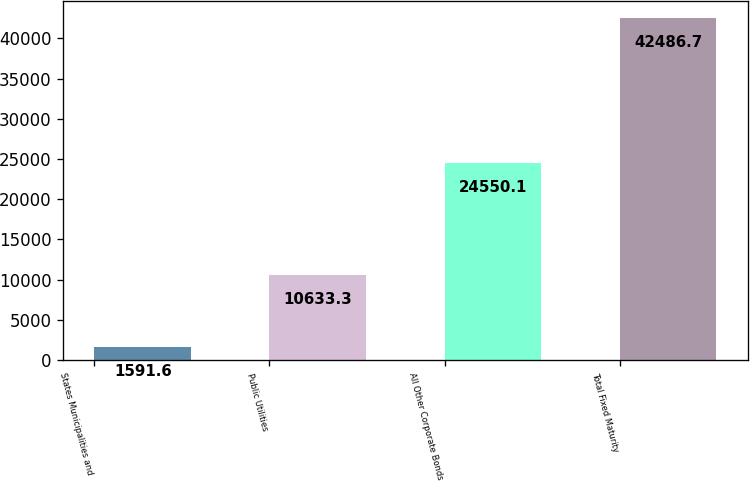<chart> <loc_0><loc_0><loc_500><loc_500><bar_chart><fcel>States Municipalities and<fcel>Public Utilities<fcel>All Other Corporate Bonds<fcel>Total Fixed Maturity<nl><fcel>1591.6<fcel>10633.3<fcel>24550.1<fcel>42486.7<nl></chart> 